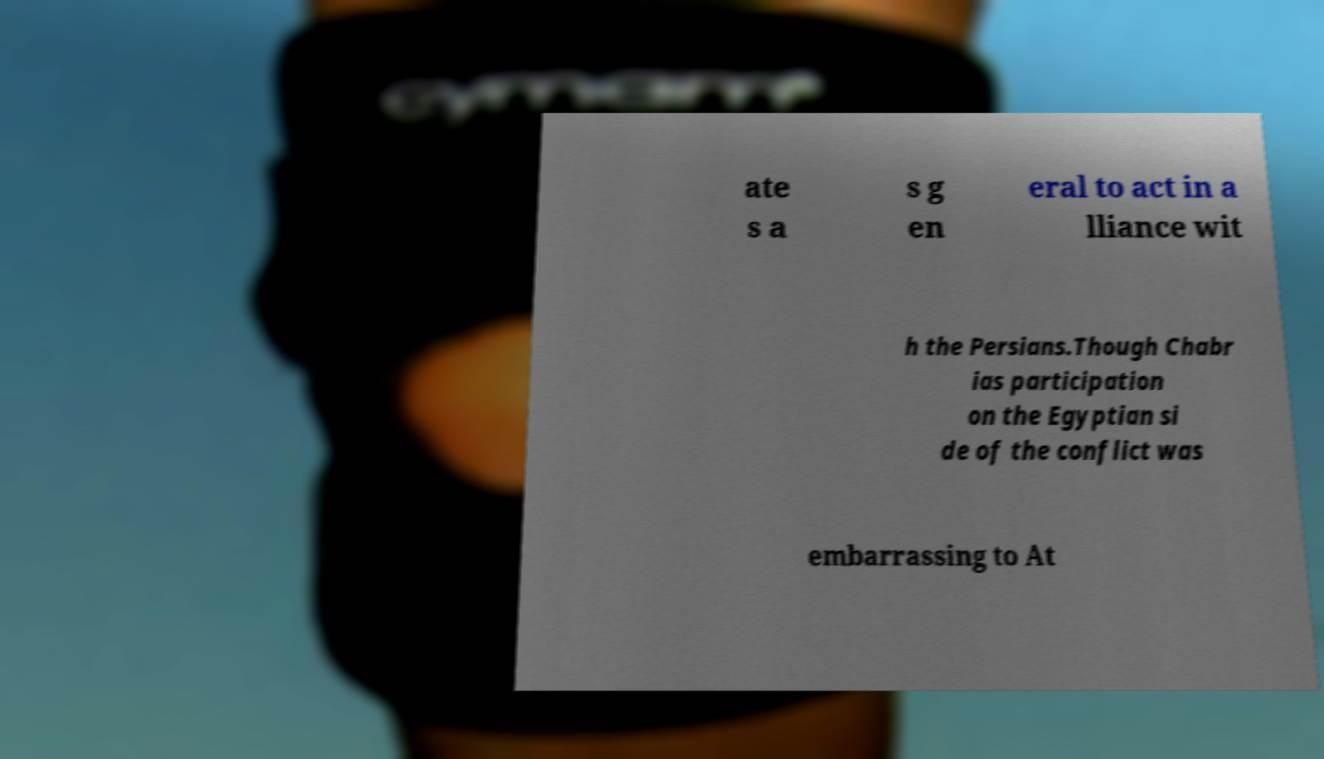Please identify and transcribe the text found in this image. ate s a s g en eral to act in a lliance wit h the Persians.Though Chabr ias participation on the Egyptian si de of the conflict was embarrassing to At 